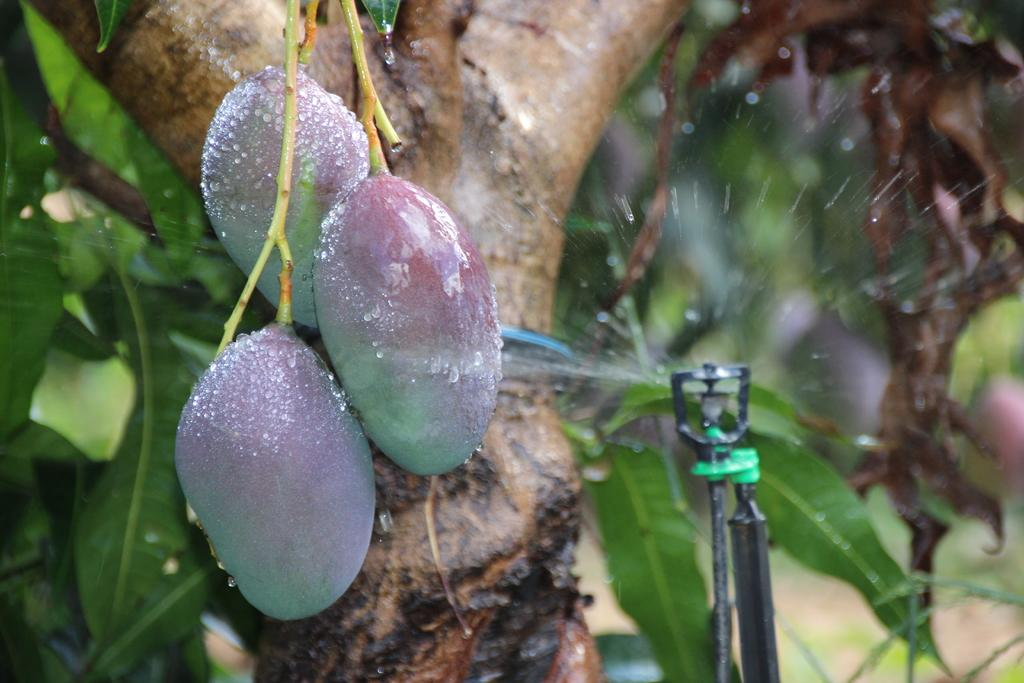What type of plant can be seen in the image? There is a tree in the image. How many fruits are visible in the image? There are three fruits in the front of the image. What can be seen on the right side of the image? There is a water sprinkler on the right side of the image. Can you describe the background of the image? The background of the image is blurry. What type of suit is the queen wearing in the image? There is no queen or suit present in the image. What sound can be heard coming from the water sprinkler in the image? The image is silent, so no sound can be heard from the water sprinkler. 